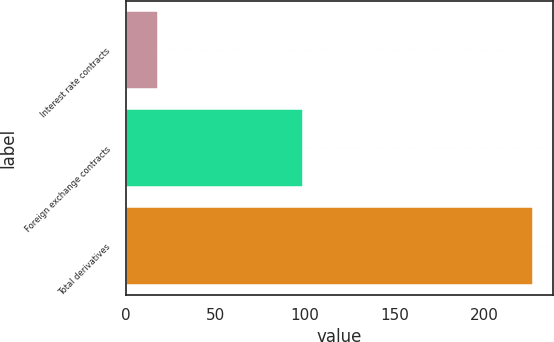Convert chart. <chart><loc_0><loc_0><loc_500><loc_500><bar_chart><fcel>Interest rate contracts<fcel>Foreign exchange contracts<fcel>Total derivatives<nl><fcel>18<fcel>99<fcel>227<nl></chart> 